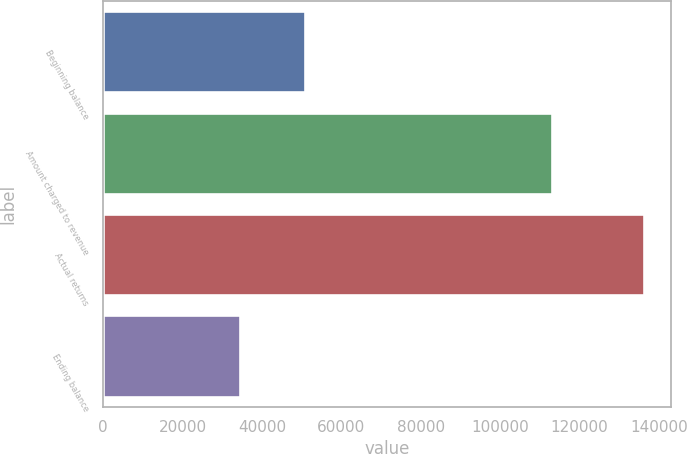<chart> <loc_0><loc_0><loc_500><loc_500><bar_chart><fcel>Beginning balance<fcel>Amount charged to revenue<fcel>Actual returns<fcel>Ending balance<nl><fcel>50943<fcel>113009<fcel>136117<fcel>34401<nl></chart> 